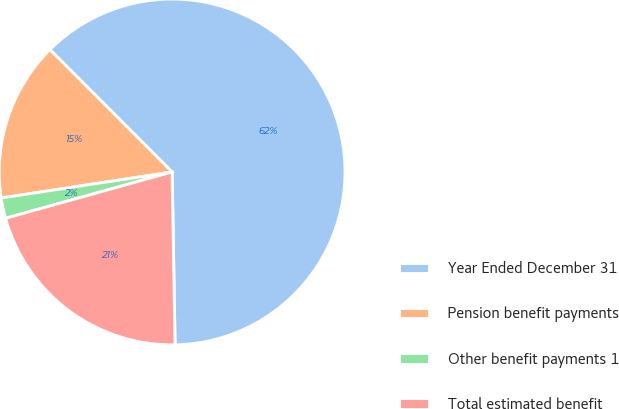<chart> <loc_0><loc_0><loc_500><loc_500><pie_chart><fcel>Year Ended December 31<fcel>Pension benefit payments<fcel>Other benefit payments 1<fcel>Total estimated benefit<nl><fcel>62.22%<fcel>14.92%<fcel>1.91%<fcel>20.95%<nl></chart> 